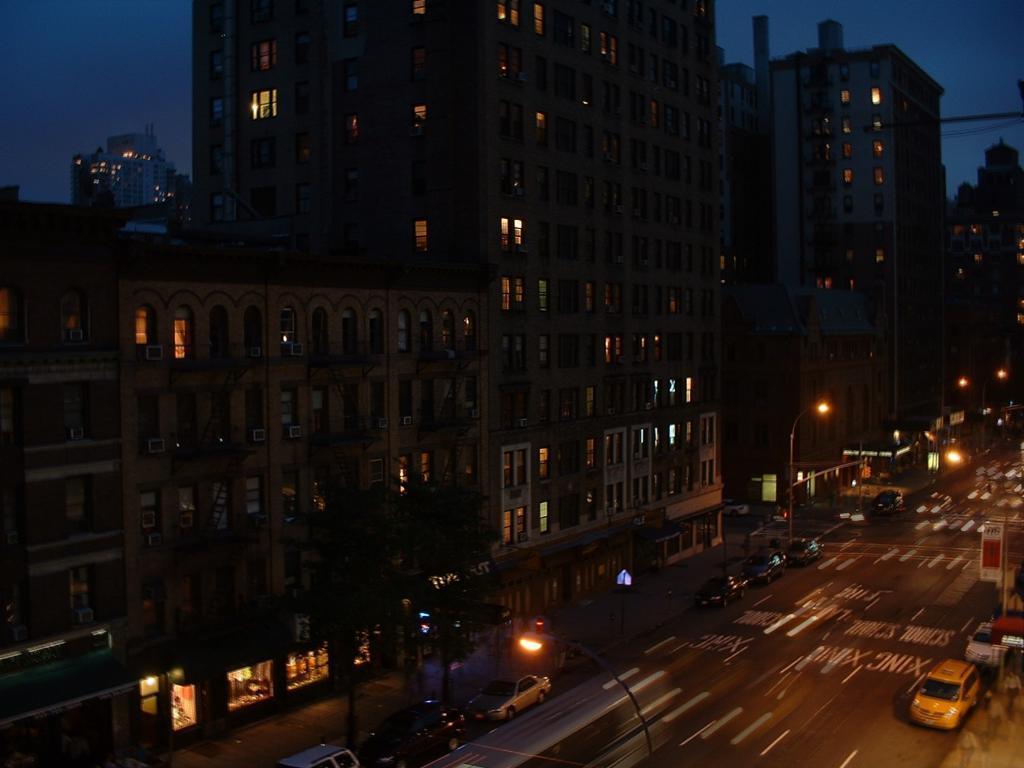Describe this image in one or two sentences. In this image we can see some buildings, windows, air conditioners, street light poles, sign boards, vehicles on the road, trees, also we can see the sky. 